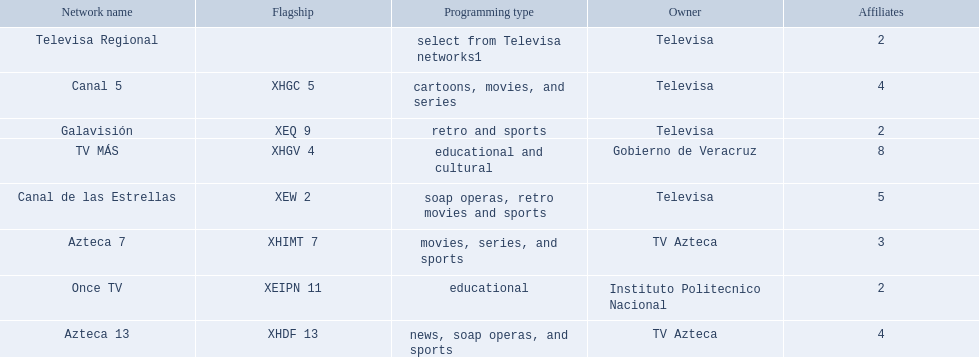Name each of tv azteca's network names. Azteca 7, Azteca 13. 